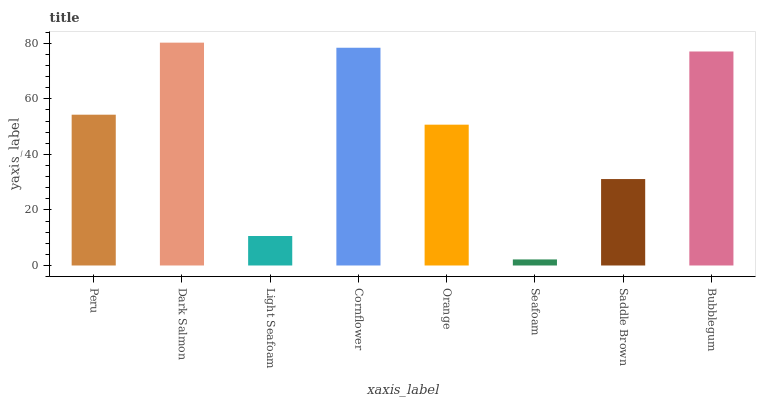Is Seafoam the minimum?
Answer yes or no. Yes. Is Dark Salmon the maximum?
Answer yes or no. Yes. Is Light Seafoam the minimum?
Answer yes or no. No. Is Light Seafoam the maximum?
Answer yes or no. No. Is Dark Salmon greater than Light Seafoam?
Answer yes or no. Yes. Is Light Seafoam less than Dark Salmon?
Answer yes or no. Yes. Is Light Seafoam greater than Dark Salmon?
Answer yes or no. No. Is Dark Salmon less than Light Seafoam?
Answer yes or no. No. Is Peru the high median?
Answer yes or no. Yes. Is Orange the low median?
Answer yes or no. Yes. Is Orange the high median?
Answer yes or no. No. Is Peru the low median?
Answer yes or no. No. 